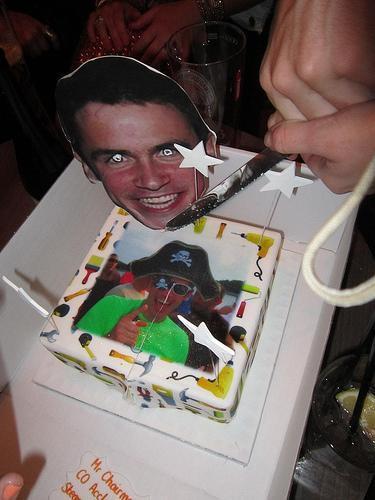How many white stars are attached to the cake?
Give a very brief answer. 4. How many photos are included in this picture?
Give a very brief answer. 2. 